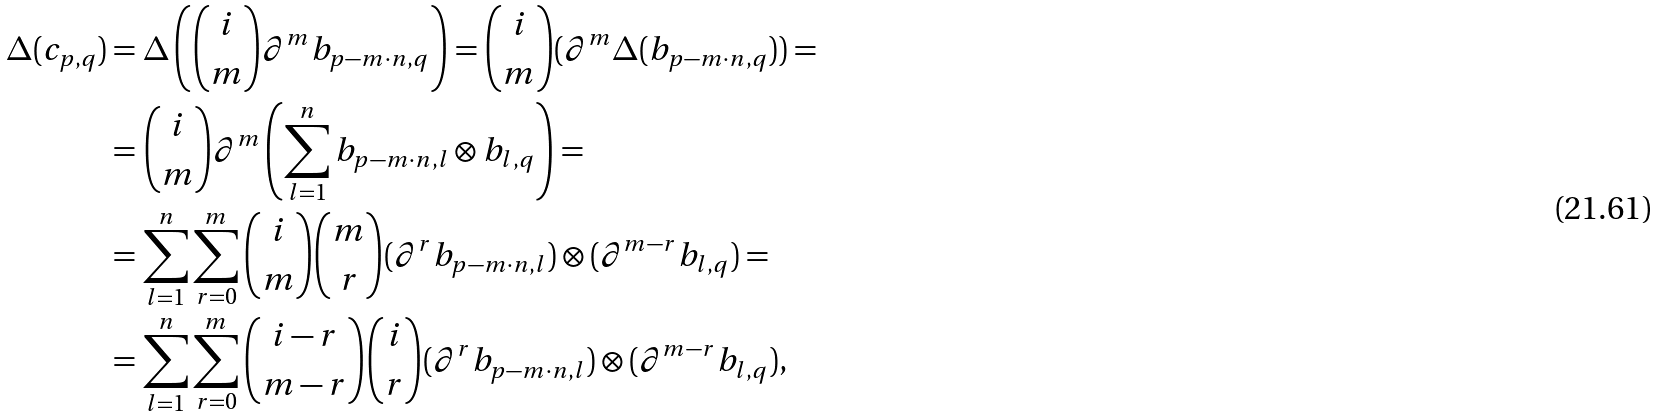Convert formula to latex. <formula><loc_0><loc_0><loc_500><loc_500>\Delta ( c _ { p , q } ) & = \Delta \left ( \binom { i } { m } \partial ^ { m } b _ { p - m \cdot n , q } \right ) = \binom { i } { m } ( \partial ^ { m } \Delta ( b _ { p - m \cdot n , q } ) ) = \\ & = \binom { i } { m } \partial ^ { m } \left ( \sum _ { l = 1 } ^ { n } b _ { p - m \cdot n , l } \otimes b _ { l , q } \right ) = \\ & = \sum _ { l = 1 } ^ { n } \sum _ { r = 0 } ^ { m } \binom { i } { m } \binom { m } { r } ( \partial ^ { r } b _ { p - m \cdot n , l } ) \otimes ( \partial ^ { m - r } b _ { l , q } ) = \\ & = \sum _ { l = 1 } ^ { n } \sum _ { r = 0 } ^ { m } \binom { i - r } { m - r } \binom { i } { r } ( \partial ^ { r } b _ { p - m \cdot n , l } ) \otimes ( \partial ^ { m - r } b _ { l , q } ) ,</formula> 